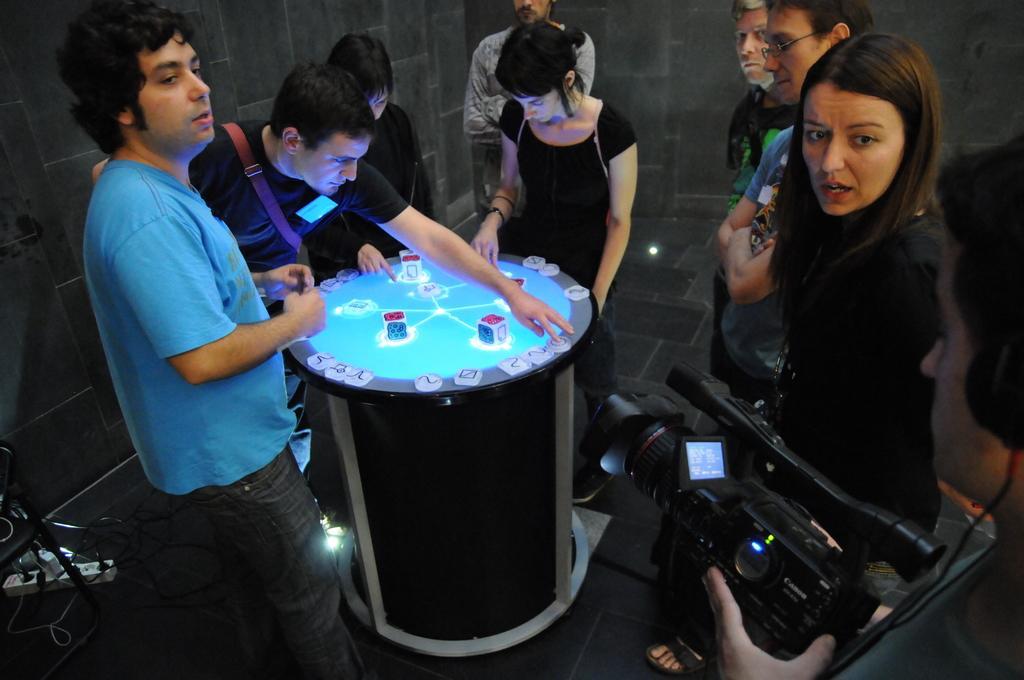Could you give a brief overview of what you see in this image? There are few persons at the left side of the image standing. Person wearing a black shirt is playing game on the play station. Person at the right side is holding a camera wearing a headphones. Beside there is a woman in black shirt. Beside there are two persons standing. 